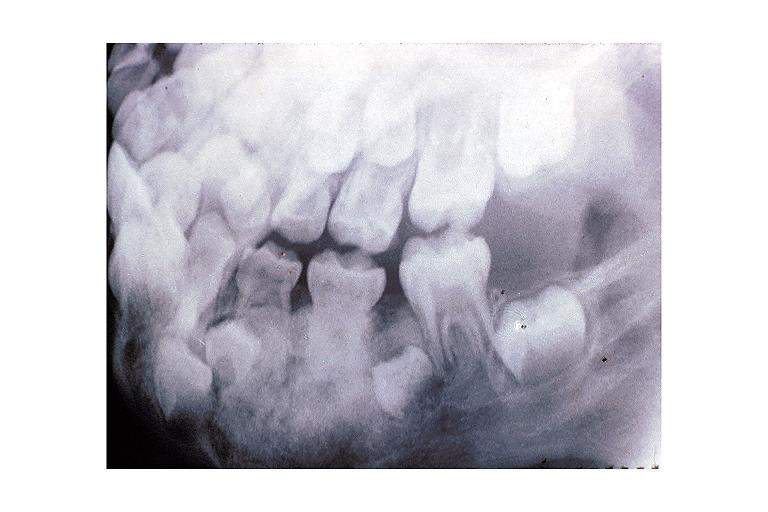where is this?
Answer the question using a single word or phrase. Oral 